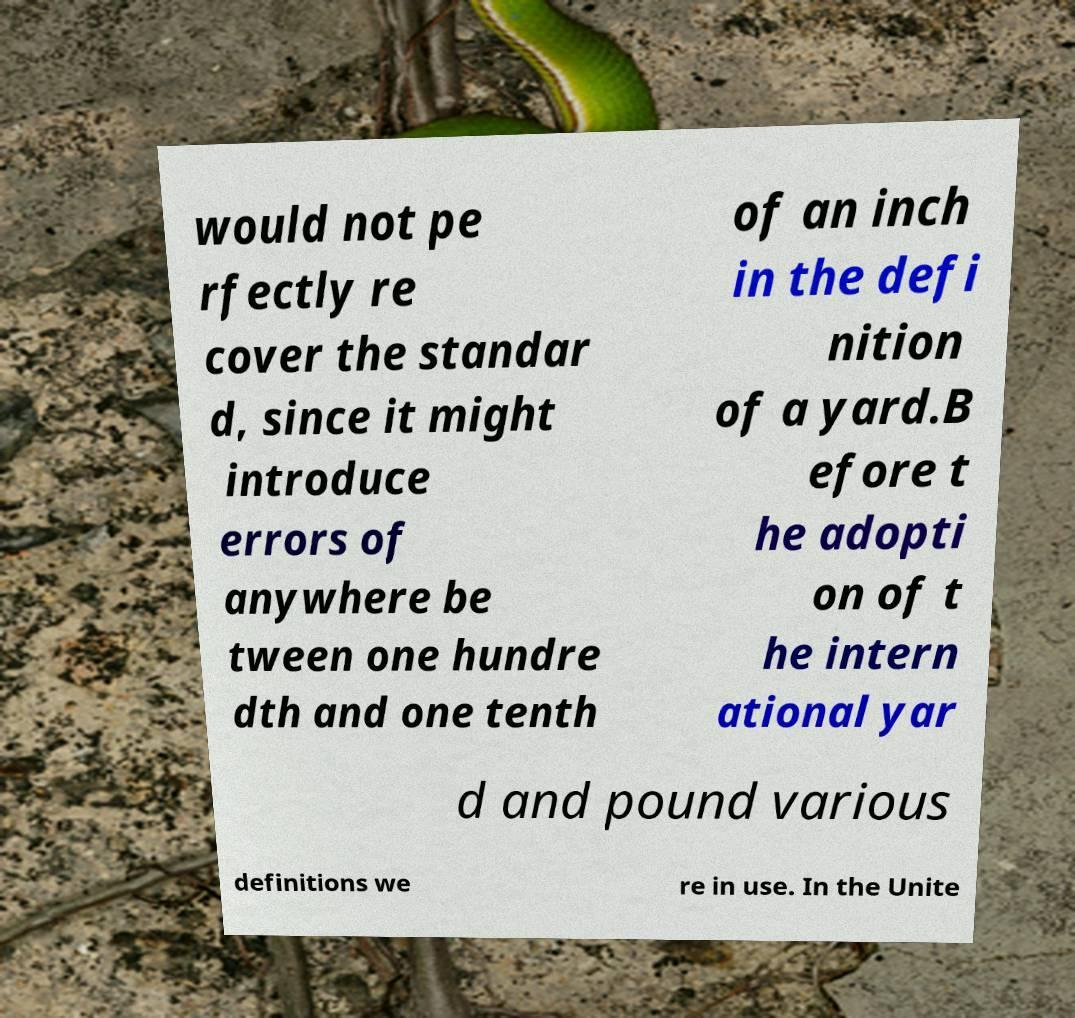For documentation purposes, I need the text within this image transcribed. Could you provide that? would not pe rfectly re cover the standar d, since it might introduce errors of anywhere be tween one hundre dth and one tenth of an inch in the defi nition of a yard.B efore t he adopti on of t he intern ational yar d and pound various definitions we re in use. In the Unite 